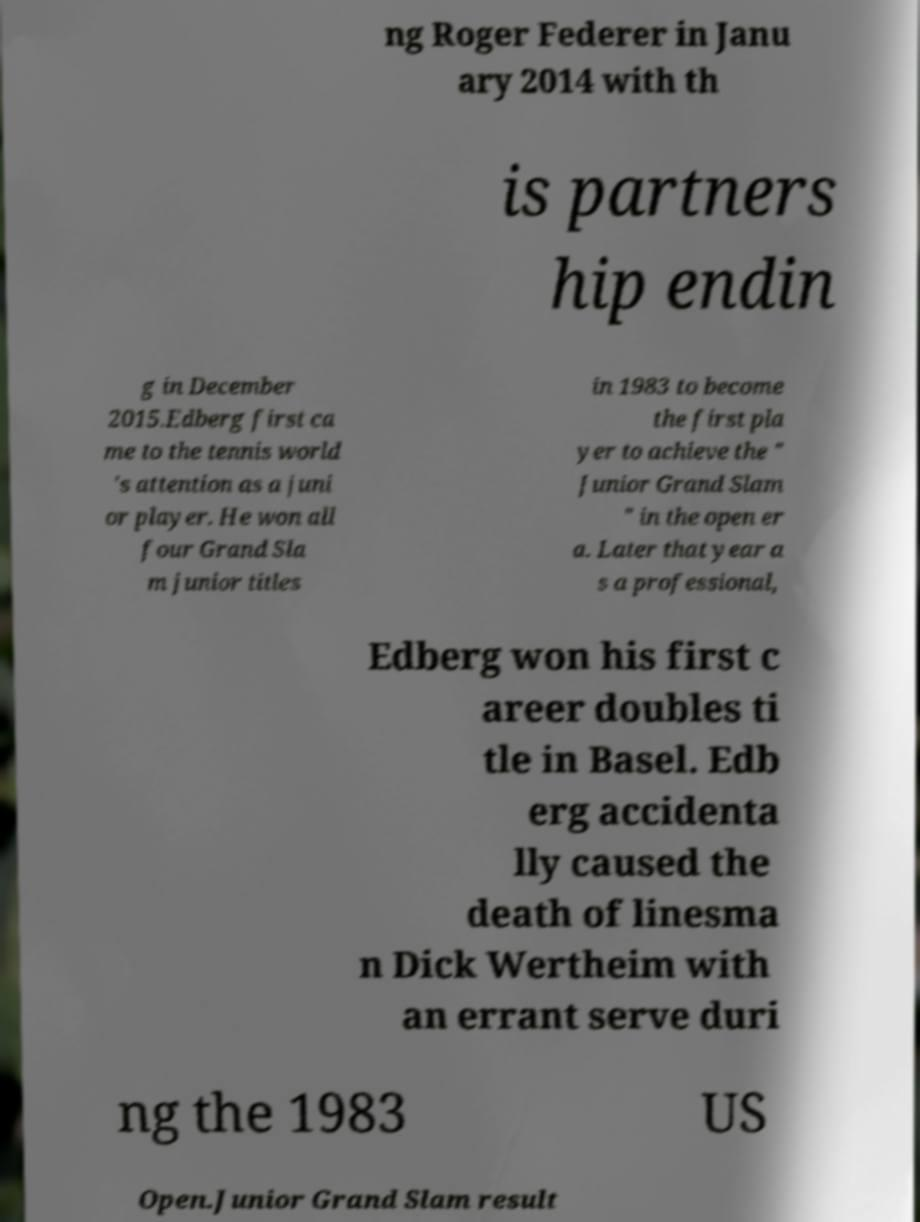Could you extract and type out the text from this image? ng Roger Federer in Janu ary 2014 with th is partners hip endin g in December 2015.Edberg first ca me to the tennis world 's attention as a juni or player. He won all four Grand Sla m junior titles in 1983 to become the first pla yer to achieve the " Junior Grand Slam " in the open er a. Later that year a s a professional, Edberg won his first c areer doubles ti tle in Basel. Edb erg accidenta lly caused the death of linesma n Dick Wertheim with an errant serve duri ng the 1983 US Open.Junior Grand Slam result 